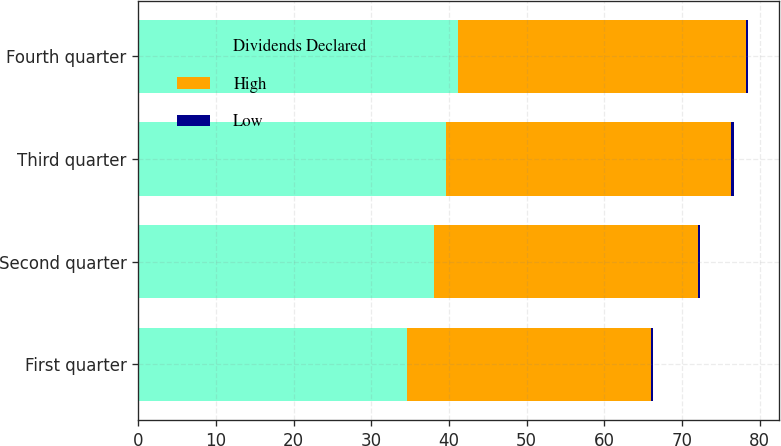Convert chart to OTSL. <chart><loc_0><loc_0><loc_500><loc_500><stacked_bar_chart><ecel><fcel>First quarter<fcel>Second quarter<fcel>Third quarter<fcel>Fourth quarter<nl><fcel>Dividends Declared<fcel>34.65<fcel>38.13<fcel>39.66<fcel>41.12<nl><fcel>High<fcel>31.42<fcel>33.99<fcel>36.72<fcel>37.18<nl><fcel>Low<fcel>0.26<fcel>0.26<fcel>0.28<fcel>0.28<nl></chart> 